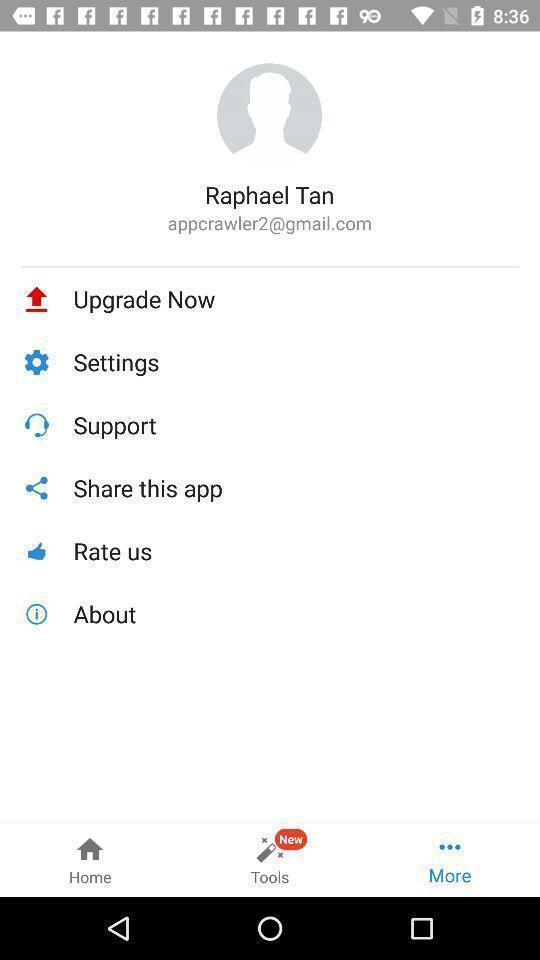Provide a detailed account of this screenshot. Page showing different options in application. 